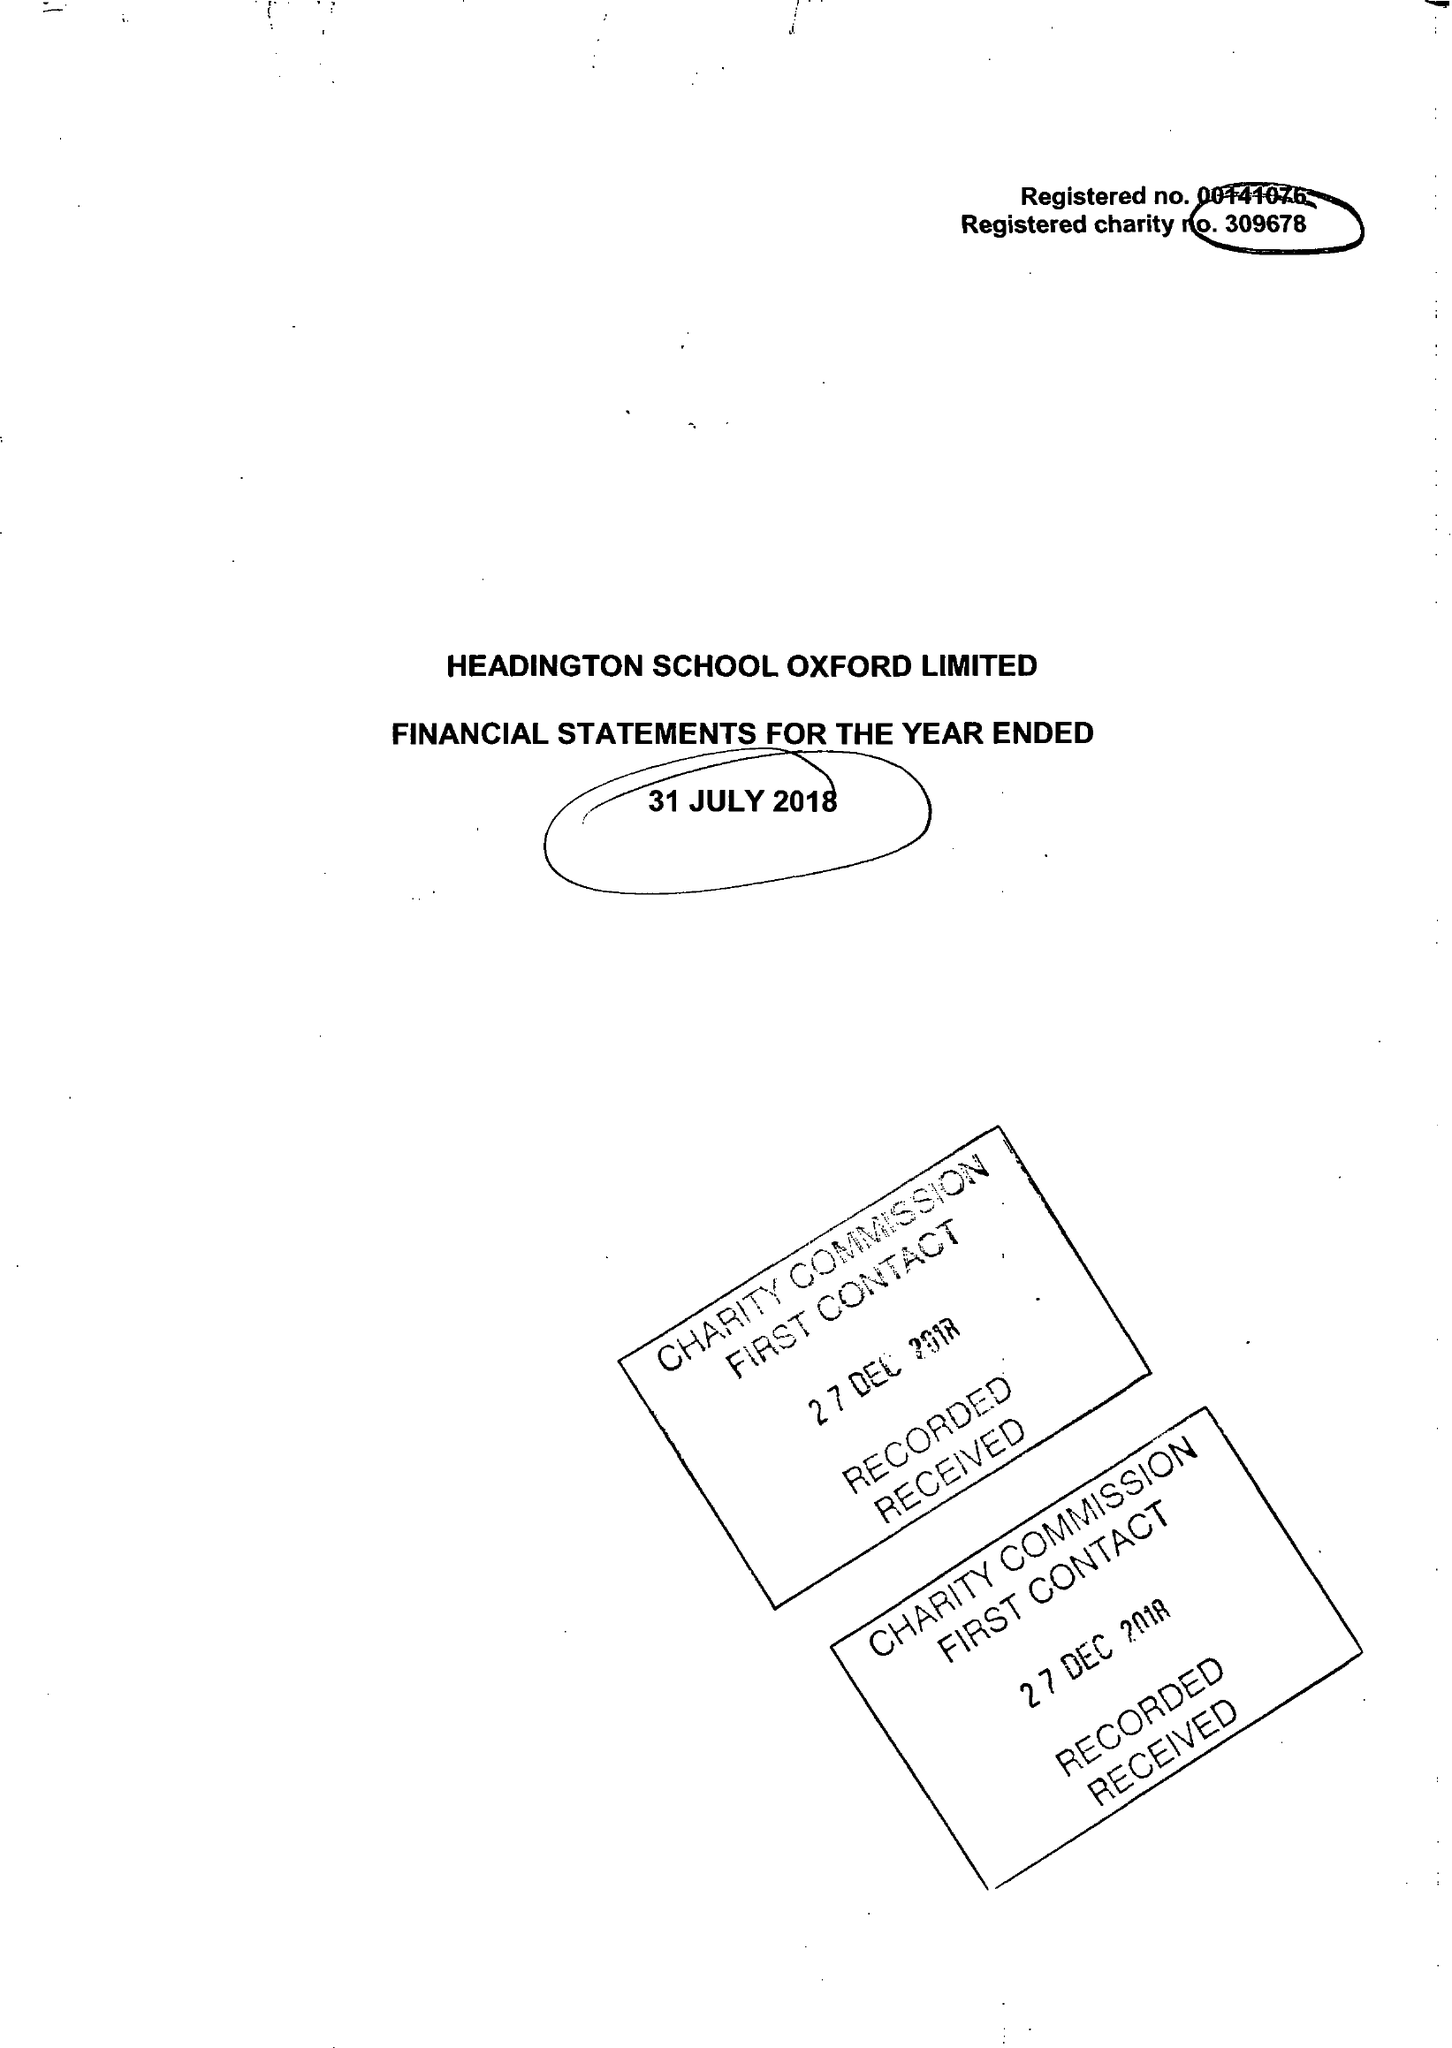What is the value for the income_annually_in_british_pounds?
Answer the question using a single word or phrase. 21704690.00 